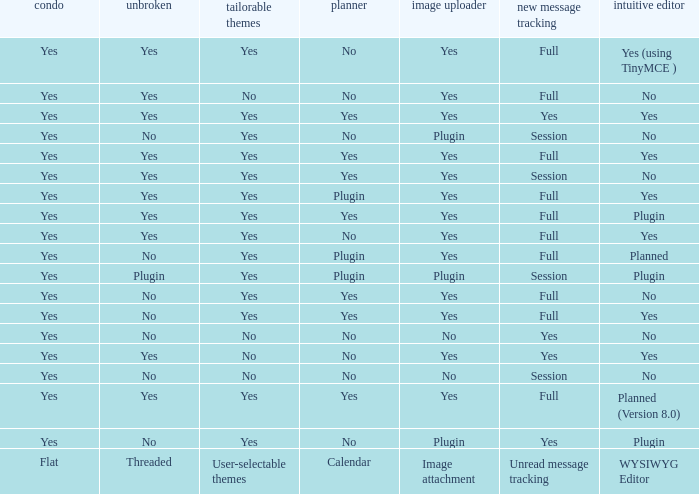Give me the full table as a dictionary. {'header': ['condo', 'unbroken', 'tailorable themes', 'planner', 'image uploader', 'new message tracking', 'intuitive editor'], 'rows': [['Yes', 'Yes', 'Yes', 'No', 'Yes', 'Full', 'Yes (using TinyMCE )'], ['Yes', 'Yes', 'No', 'No', 'Yes', 'Full', 'No'], ['Yes', 'Yes', 'Yes', 'Yes', 'Yes', 'Yes', 'Yes'], ['Yes', 'No', 'Yes', 'No', 'Plugin', 'Session', 'No'], ['Yes', 'Yes', 'Yes', 'Yes', 'Yes', 'Full', 'Yes'], ['Yes', 'Yes', 'Yes', 'Yes', 'Yes', 'Session', 'No'], ['Yes', 'Yes', 'Yes', 'Plugin', 'Yes', 'Full', 'Yes'], ['Yes', 'Yes', 'Yes', 'Yes', 'Yes', 'Full', 'Plugin'], ['Yes', 'Yes', 'Yes', 'No', 'Yes', 'Full', 'Yes'], ['Yes', 'No', 'Yes', 'Plugin', 'Yes', 'Full', 'Planned'], ['Yes', 'Plugin', 'Yes', 'Plugin', 'Plugin', 'Session', 'Plugin'], ['Yes', 'No', 'Yes', 'Yes', 'Yes', 'Full', 'No'], ['Yes', 'No', 'Yes', 'Yes', 'Yes', 'Full', 'Yes'], ['Yes', 'No', 'No', 'No', 'No', 'Yes', 'No'], ['Yes', 'Yes', 'No', 'No', 'Yes', 'Yes', 'Yes'], ['Yes', 'No', 'No', 'No', 'No', 'Session', 'No'], ['Yes', 'Yes', 'Yes', 'Yes', 'Yes', 'Full', 'Planned (Version 8.0)'], ['Yes', 'No', 'Yes', 'No', 'Plugin', 'Yes', 'Plugin'], ['Flat', 'Threaded', 'User-selectable themes', 'Calendar', 'Image attachment', 'Unread message tracking', 'WYSIWYG Editor']]} Which Calendar has a User-selectable themes of user-selectable themes? Calendar. 